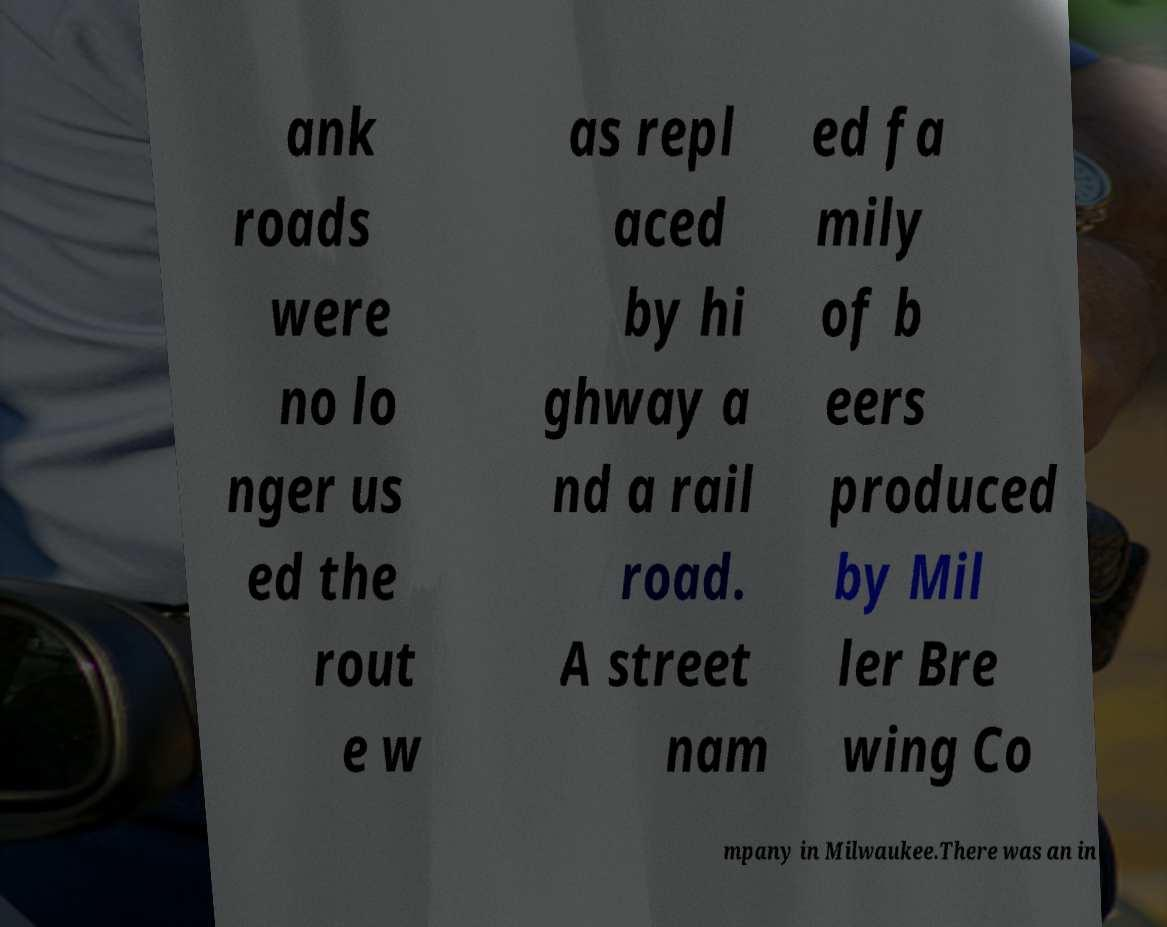Could you extract and type out the text from this image? ank roads were no lo nger us ed the rout e w as repl aced by hi ghway a nd a rail road. A street nam ed fa mily of b eers produced by Mil ler Bre wing Co mpany in Milwaukee.There was an in 